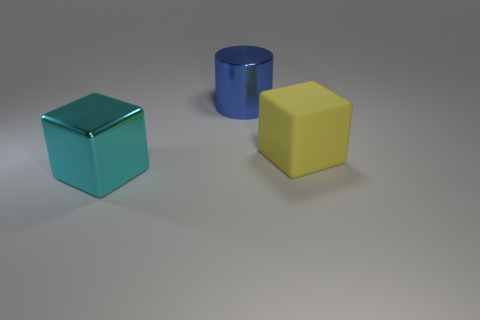Could you describe the lighting and shadows in this image? The lighting in the image is soft and diffuse, casting gentle shadows directly underneath the objects. This suggests the light source is probably broad and located above the scene, as indicated by the lack of harsh shadows and even illumination across the objects' surfaces. 